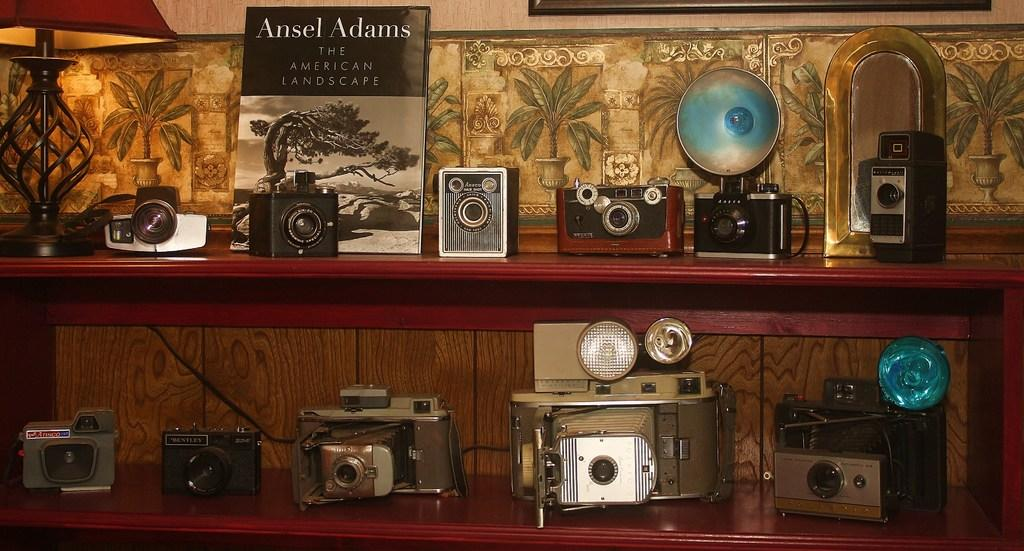<image>
Provide a brief description of the given image. a book that is about The American Landscape 